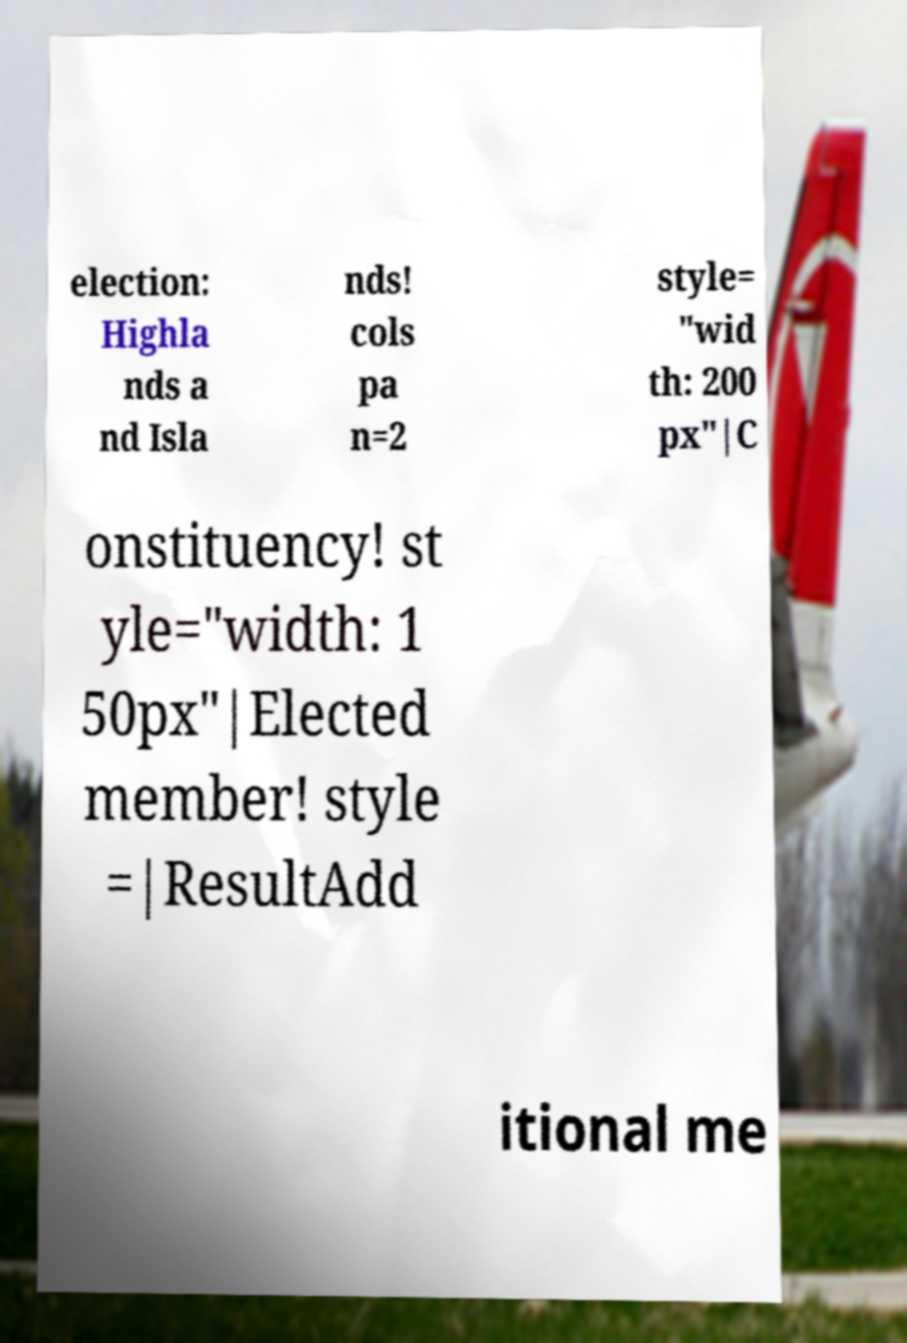Can you read and provide the text displayed in the image?This photo seems to have some interesting text. Can you extract and type it out for me? election: Highla nds a nd Isla nds! cols pa n=2 style= "wid th: 200 px"|C onstituency! st yle="width: 1 50px"|Elected member! style =|ResultAdd itional me 